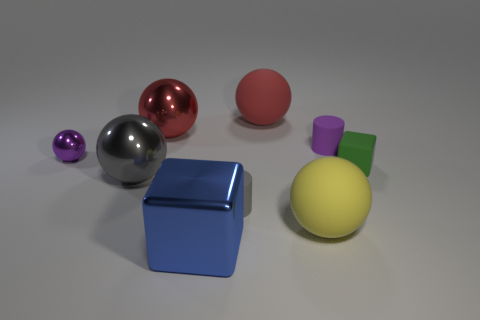What shape is the small thing that is the same color as the small shiny ball?
Provide a short and direct response. Cylinder. What number of other objects are the same size as the yellow matte ball?
Provide a succinct answer. 4. There is a rubber sphere that is behind the tiny matte object that is behind the tiny matte block; what is its size?
Provide a short and direct response. Large. What color is the big rubber sphere in front of the red rubber object that is behind the small purple object that is to the left of the big blue metallic cube?
Make the answer very short. Yellow. There is a object that is both left of the small gray cylinder and in front of the large gray object; what size is it?
Offer a terse response. Large. How many other objects are the same shape as the big red matte object?
Keep it short and to the point. 4. How many blocks are either big red rubber objects or gray rubber objects?
Offer a terse response. 0. There is a large red object that is in front of the object that is behind the big red shiny ball; is there a small purple metallic ball right of it?
Keep it short and to the point. No. There is another thing that is the same shape as the small green matte thing; what color is it?
Make the answer very short. Blue. How many yellow things are either large rubber objects or matte objects?
Provide a succinct answer. 1. 